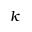Convert formula to latex. <formula><loc_0><loc_0><loc_500><loc_500>k</formula> 